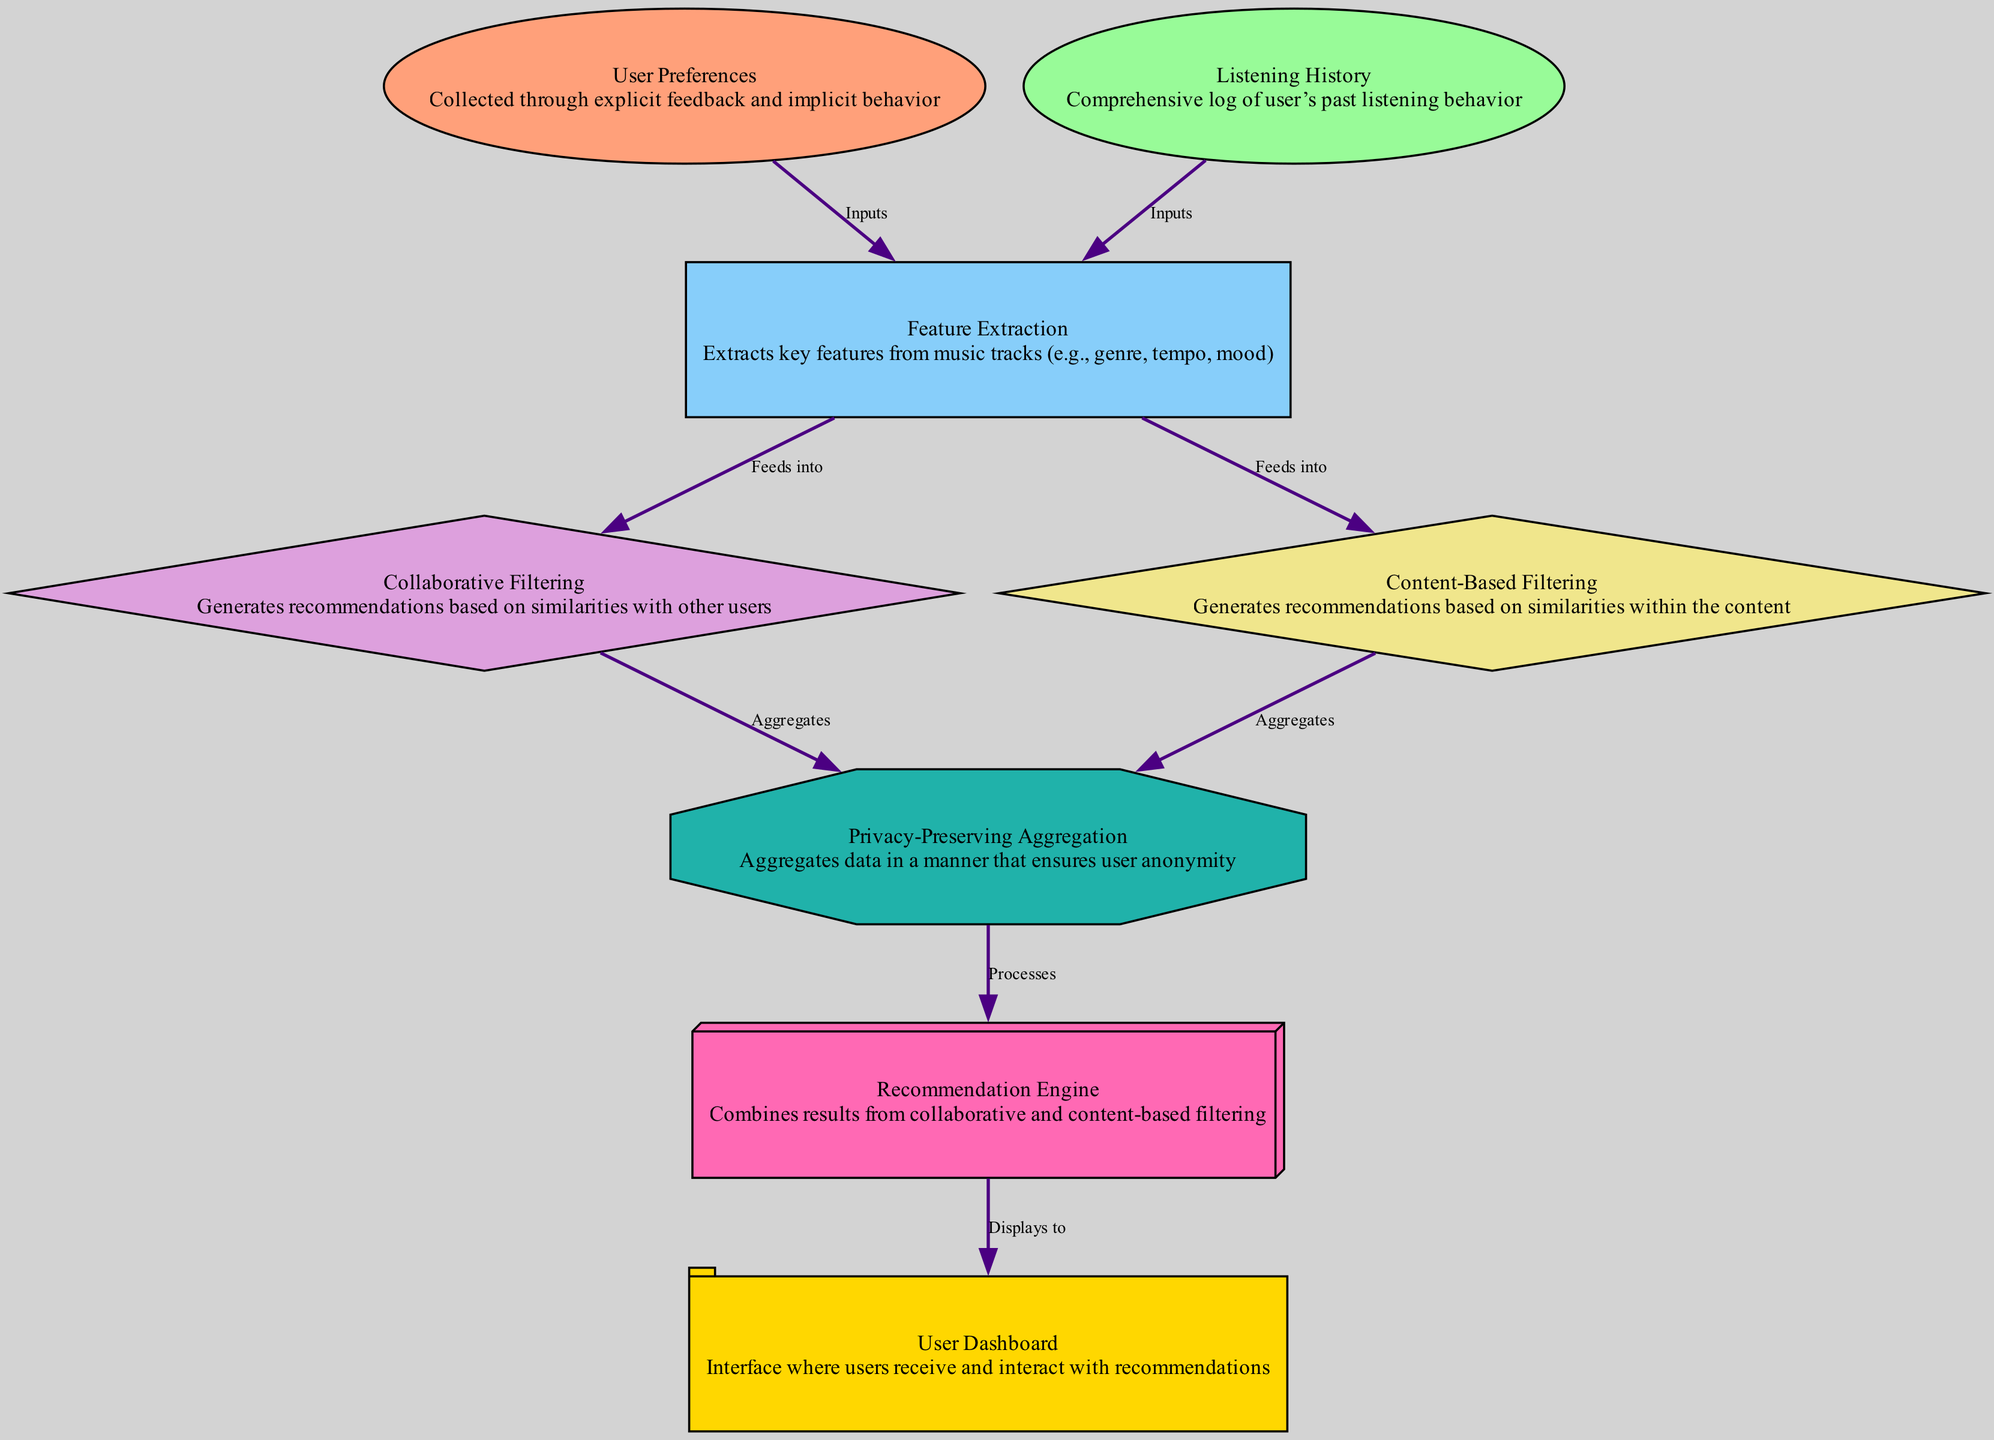What are the two main inputs for feature extraction? The diagram indicates that the two main inputs for feature extraction are "User Preferences" and "Listening History," which are directly connected to the feature extraction node.
Answer: User Preferences, Listening History How many nodes are present in the diagram? By counting the distinct labeled nodes in the diagram, we can see there are a total of eight nodes listed.
Answer: 8 What is the shape of the Privacy-Preserving Aggregation node? The diagram shows that the Privacy-Preserving Aggregation node is represented as an octagon.
Answer: Octagon How does the Recommendation Engine obtain its data? According to the diagram, the Recommendation Engine processes data from the Privacy-Preserving Aggregation, which aggregates results from both Collaborative Filtering and Content-Based Filtering.
Answer: Processes aggregated data Which nodes feed into the Content-Based Filtering? The diagram indicates that the Content-Based Filtering node receives input from the Feature Extraction node, which is crucial for its operation.
Answer: Feature Extraction How is user privacy ensured in this system? The system ensures user privacy through a Privacy-Preserving Aggregation process, which aggregates data while maintaining user anonymity.
Answer: Privacy-Preserving Aggregation What links the Listening History to Feature Extraction? The edge labeled "Inputs" shows that the Listening History node directly links to Feature Extraction, signifying it as an input.
Answer: Inputs edge Which node displays music recommendations to the user? The User Dashboard node is explicitly mentioned as the interface where users receive and interact with their music recommendations.
Answer: User Dashboard 